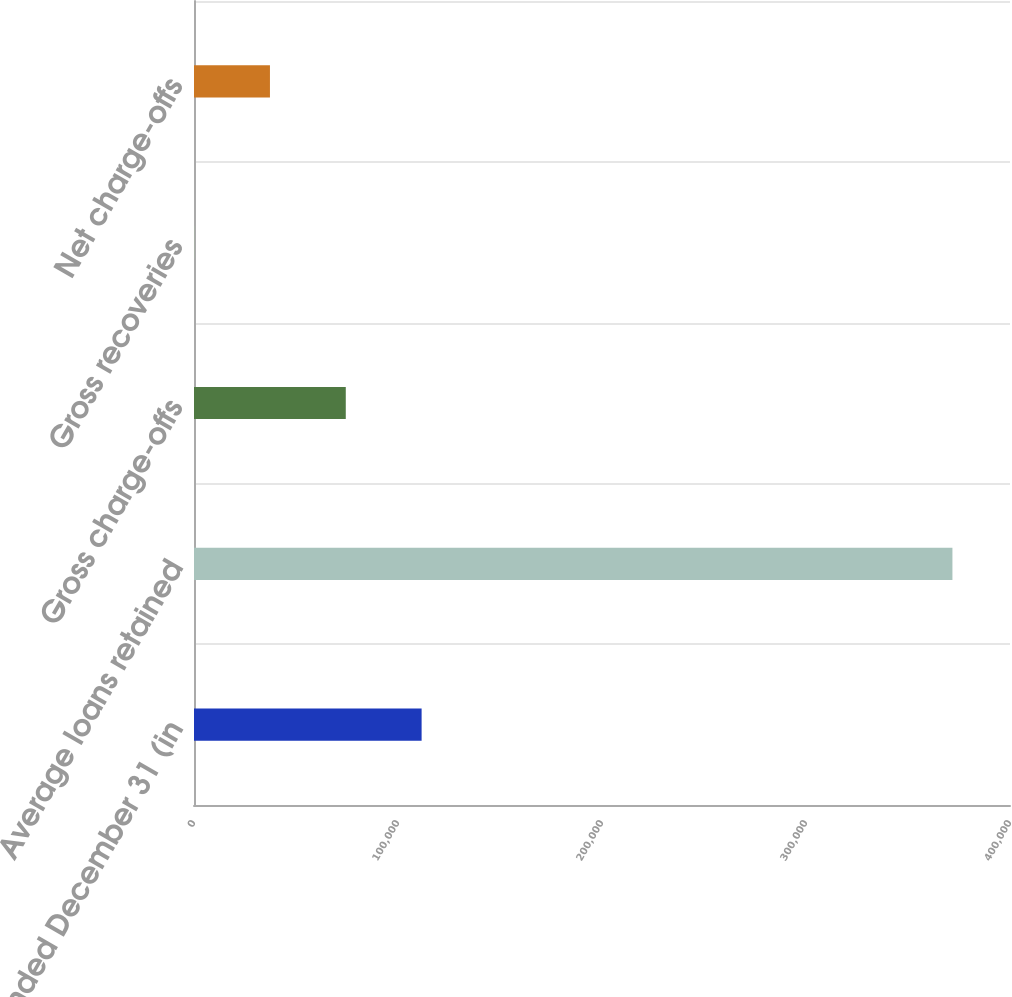Convert chart. <chart><loc_0><loc_0><loc_500><loc_500><bar_chart><fcel>Year ended December 31 (in<fcel>Average loans retained<fcel>Gross charge-offs<fcel>Gross recoveries<fcel>Net charge-offs<nl><fcel>111573<fcel>371778<fcel>74401.2<fcel>57<fcel>37229.1<nl></chart> 